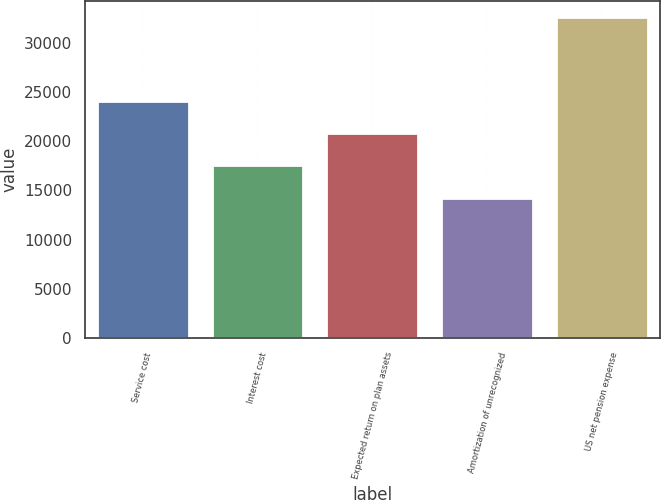Convert chart to OTSL. <chart><loc_0><loc_0><loc_500><loc_500><bar_chart><fcel>Service cost<fcel>Interest cost<fcel>Expected return on plan assets<fcel>Amortization of unrecognized<fcel>US net pension expense<nl><fcel>24051<fcel>17537<fcel>20794<fcel>14280<fcel>32657<nl></chart> 